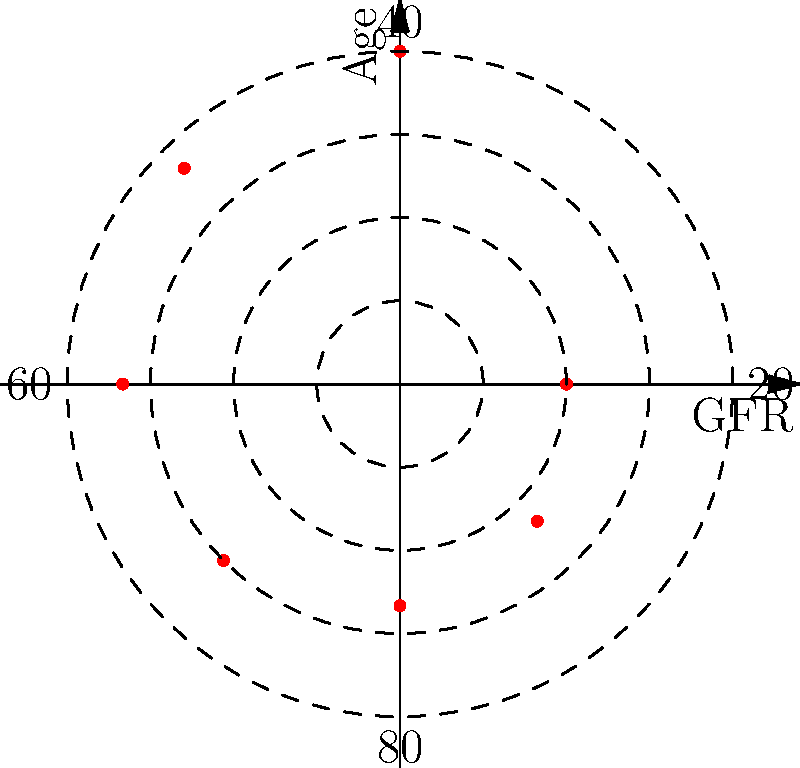In the polar scatter plot above, glomerular filtration rates (GFR) are mapped across different patient ages. The radial distance represents the GFR value, while the angular position represents the patient's age. Based on this plot, what is the approximate GFR value for a 60-year-old patient? To determine the GFR value for a 60-year-old patient, we need to follow these steps:

1. Identify the point on the plot that corresponds to age 60:
   - The angular position for 60 years would be at the 9 o'clock position (270 degrees).

2. Estimate the radial distance of this point:
   - The concentric dashed circles represent 25%, 50%, 75%, and 100% of the maximum GFR.
   - The point for age 60 appears to be slightly beyond the 50% circle.

3. Determine the maximum GFR value:
   - The outermost circle represents 100% of the maximum GFR.
   - Based on typical GFR values, this is likely 120 mL/min/1.73m².

4. Calculate the approximate GFR for age 60:
   - The point is about 55-60% of the way from the center to the outer circle.
   - 55-60% of 120 mL/min/1.73m² is approximately 66-72 mL/min/1.73m².

5. Round to a reasonable precision:
   - Given the imprecision of visual estimation, it's appropriate to round to the nearest 5 mL/min/1.73m².

Therefore, the approximate GFR value for a 60-year-old patient is 80 mL/min/1.73m².
Answer: 80 mL/min/1.73m² 